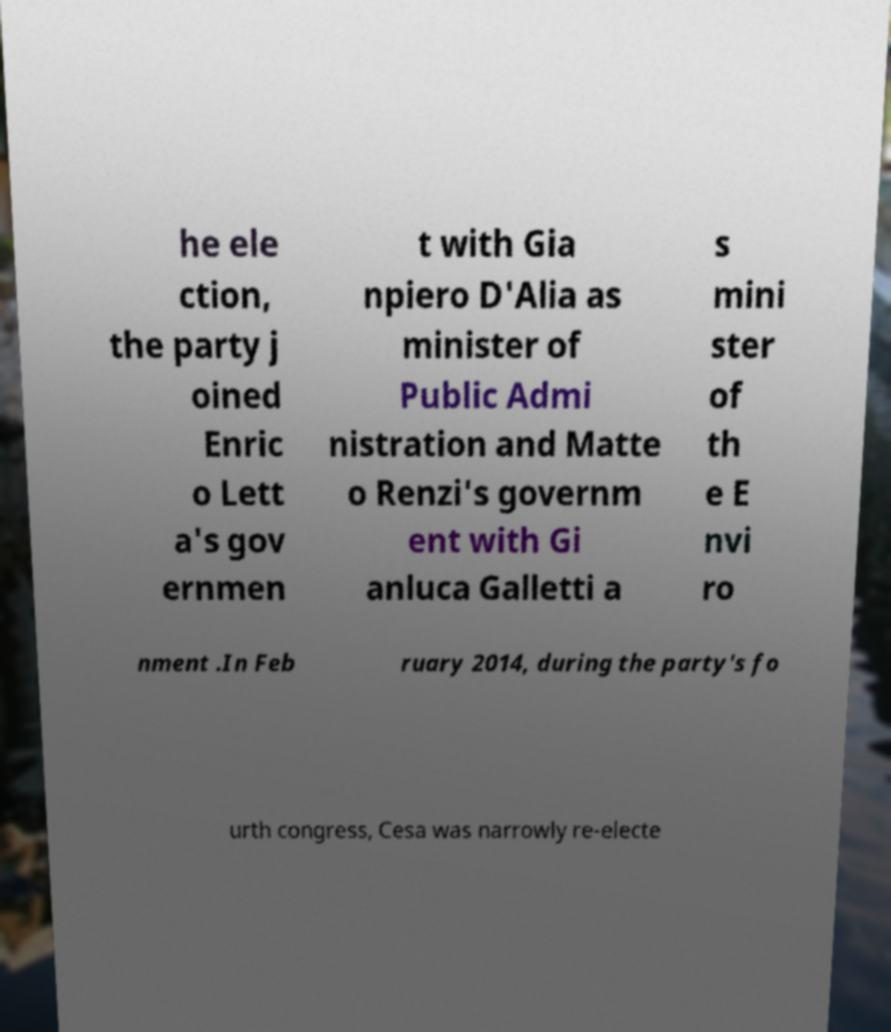For documentation purposes, I need the text within this image transcribed. Could you provide that? he ele ction, the party j oined Enric o Lett a's gov ernmen t with Gia npiero D'Alia as minister of Public Admi nistration and Matte o Renzi's governm ent with Gi anluca Galletti a s mini ster of th e E nvi ro nment .In Feb ruary 2014, during the party's fo urth congress, Cesa was narrowly re-electe 